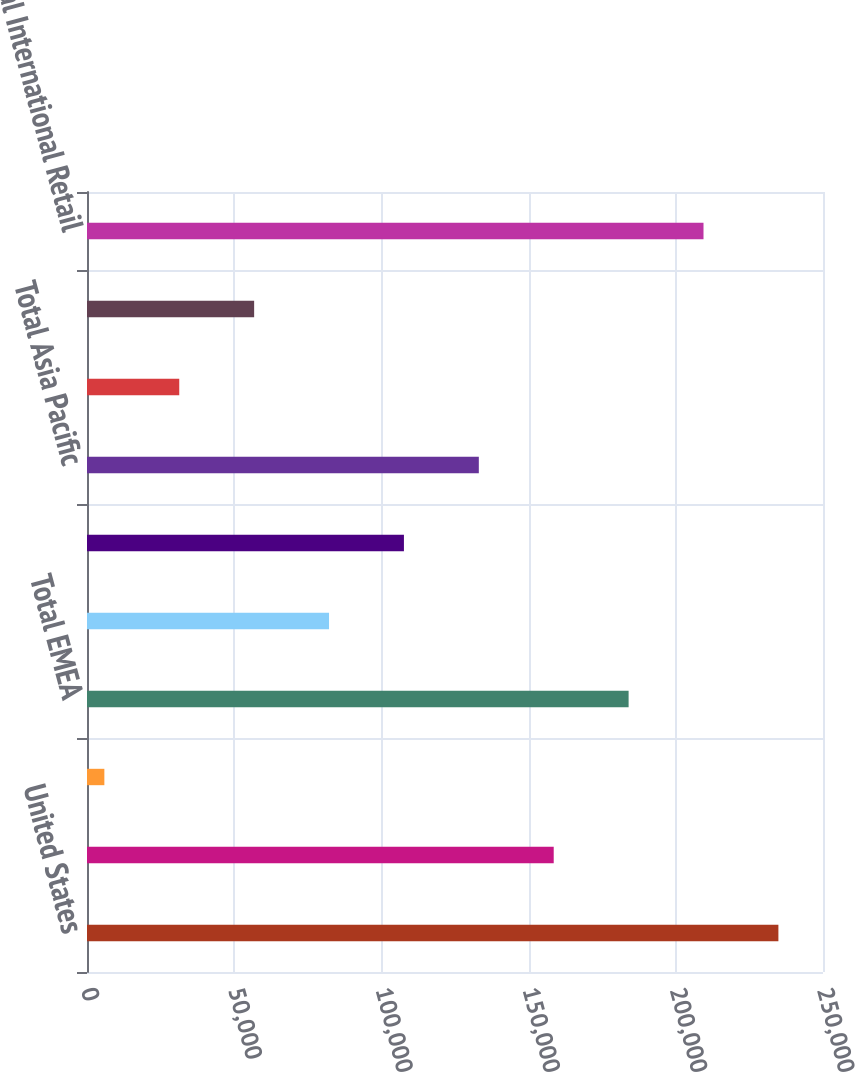Convert chart. <chart><loc_0><loc_0><loc_500><loc_500><bar_chart><fcel>United States<fcel>Europe (b)<fcel>EMEA - Other<fcel>Total EMEA<fcel>Japan<fcel>Asia Pacific - Other<fcel>Total Asia Pacific<fcel>Latin America<fcel>Canada<fcel>Total International Retail<nl><fcel>234850<fcel>158532<fcel>5896<fcel>183971<fcel>82213.9<fcel>107653<fcel>133092<fcel>31335.3<fcel>56774.6<fcel>209410<nl></chart> 